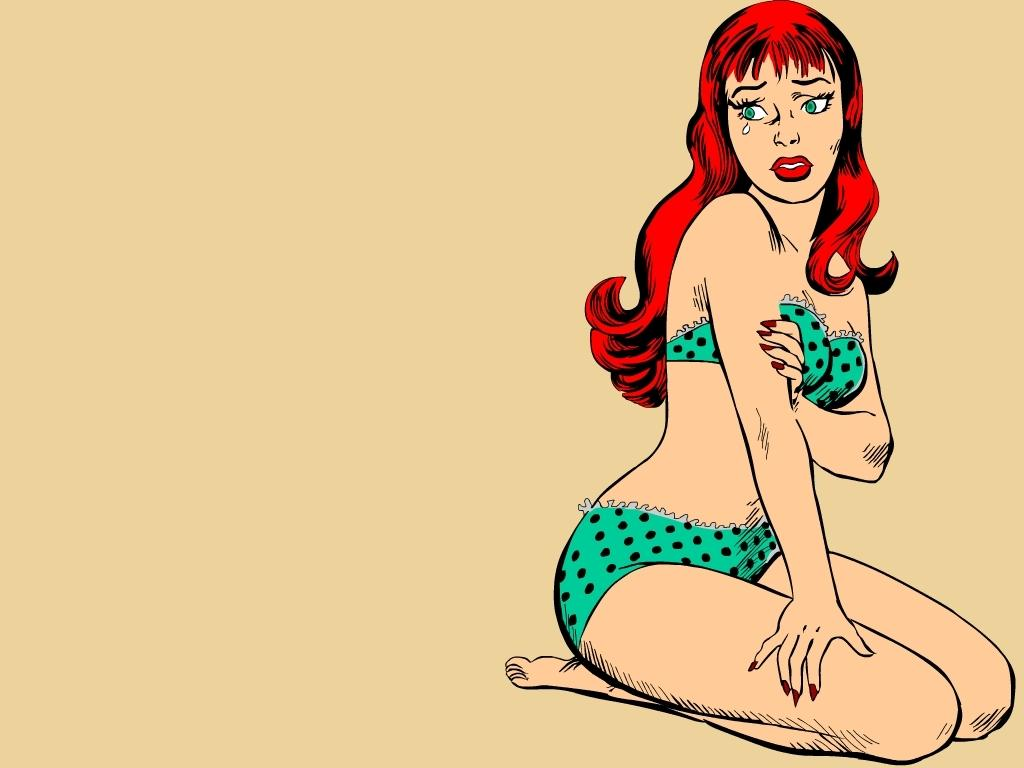What type of image is depicted in the center of the picture? There is a cartoon image of a woman in the image. What can be seen in the background of the image? The background of the image features a plane. How does the baby contribute to the friction in the image? There is no baby present in the image, so the concept of friction does not apply. 